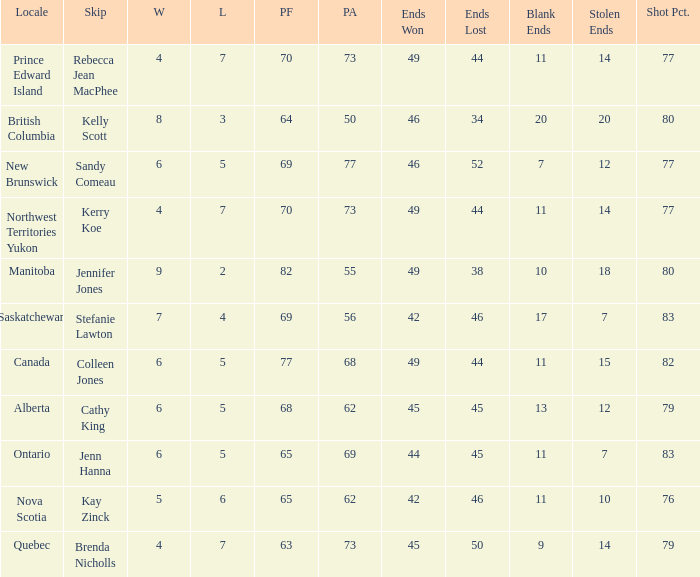What is the PA when the skip is Colleen Jones? 68.0. Could you parse the entire table? {'header': ['Locale', 'Skip', 'W', 'L', 'PF', 'PA', 'Ends Won', 'Ends Lost', 'Blank Ends', 'Stolen Ends', 'Shot Pct.'], 'rows': [['Prince Edward Island', 'Rebecca Jean MacPhee', '4', '7', '70', '73', '49', '44', '11', '14', '77'], ['British Columbia', 'Kelly Scott', '8', '3', '64', '50', '46', '34', '20', '20', '80'], ['New Brunswick', 'Sandy Comeau', '6', '5', '69', '77', '46', '52', '7', '12', '77'], ['Northwest Territories Yukon', 'Kerry Koe', '4', '7', '70', '73', '49', '44', '11', '14', '77'], ['Manitoba', 'Jennifer Jones', '9', '2', '82', '55', '49', '38', '10', '18', '80'], ['Saskatchewan', 'Stefanie Lawton', '7', '4', '69', '56', '42', '46', '17', '7', '83'], ['Canada', 'Colleen Jones', '6', '5', '77', '68', '49', '44', '11', '15', '82'], ['Alberta', 'Cathy King', '6', '5', '68', '62', '45', '45', '13', '12', '79'], ['Ontario', 'Jenn Hanna', '6', '5', '65', '69', '44', '45', '11', '7', '83'], ['Nova Scotia', 'Kay Zinck', '5', '6', '65', '62', '42', '46', '11', '10', '76'], ['Quebec', 'Brenda Nicholls', '4', '7', '63', '73', '45', '50', '9', '14', '79']]} 